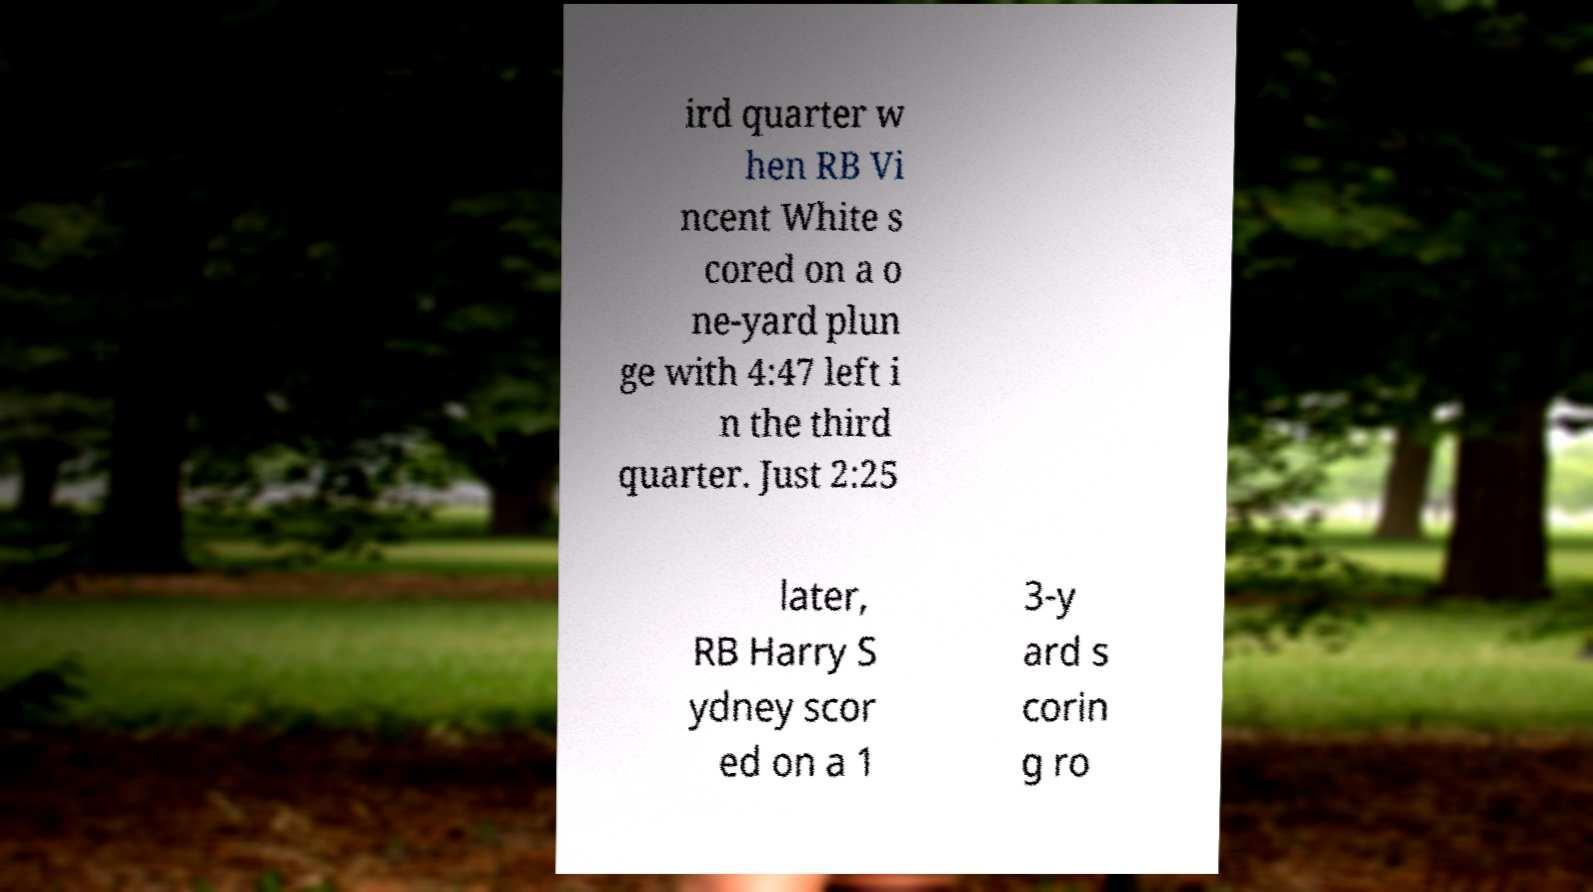Please identify and transcribe the text found in this image. ird quarter w hen RB Vi ncent White s cored on a o ne-yard plun ge with 4:47 left i n the third quarter. Just 2:25 later, RB Harry S ydney scor ed on a 1 3-y ard s corin g ro 